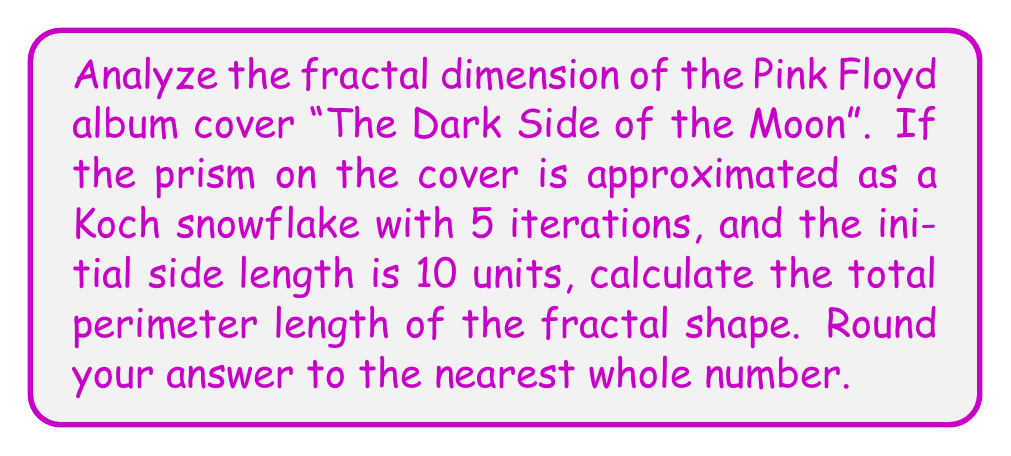Give your solution to this math problem. Let's approach this step-by-step:

1) The Koch snowflake is a fractal curve. For each iteration, each line segment is divided into three equal parts, and the middle segment is replaced by two segments forming an equilateral triangle.

2) The Koch snowflake starts with an equilateral triangle. After each iteration, the number of sides increases by a factor of 4, and the length of each side decreases by a factor of 3.

3) Let's calculate the number of sides after 5 iterations:
   Initial number of sides: 3
   After 5 iterations: $3 * 4^5 = 3 * 1024 = 3072$ sides

4) Now, let's calculate the length of each side after 5 iterations:
   Initial length: 10 units
   After 5 iterations: $10 * (\frac{1}{3})^5 = 10 * \frac{1}{243} \approx 0.0412$ units

5) To find the total perimeter length, we multiply the number of sides by the length of each side:

   $$ \text{Perimeter} = 3072 * 0.0412 \approx 126.5664 \text{ units} $$

6) Rounding to the nearest whole number gives us 127 units.
Answer: 127 units 